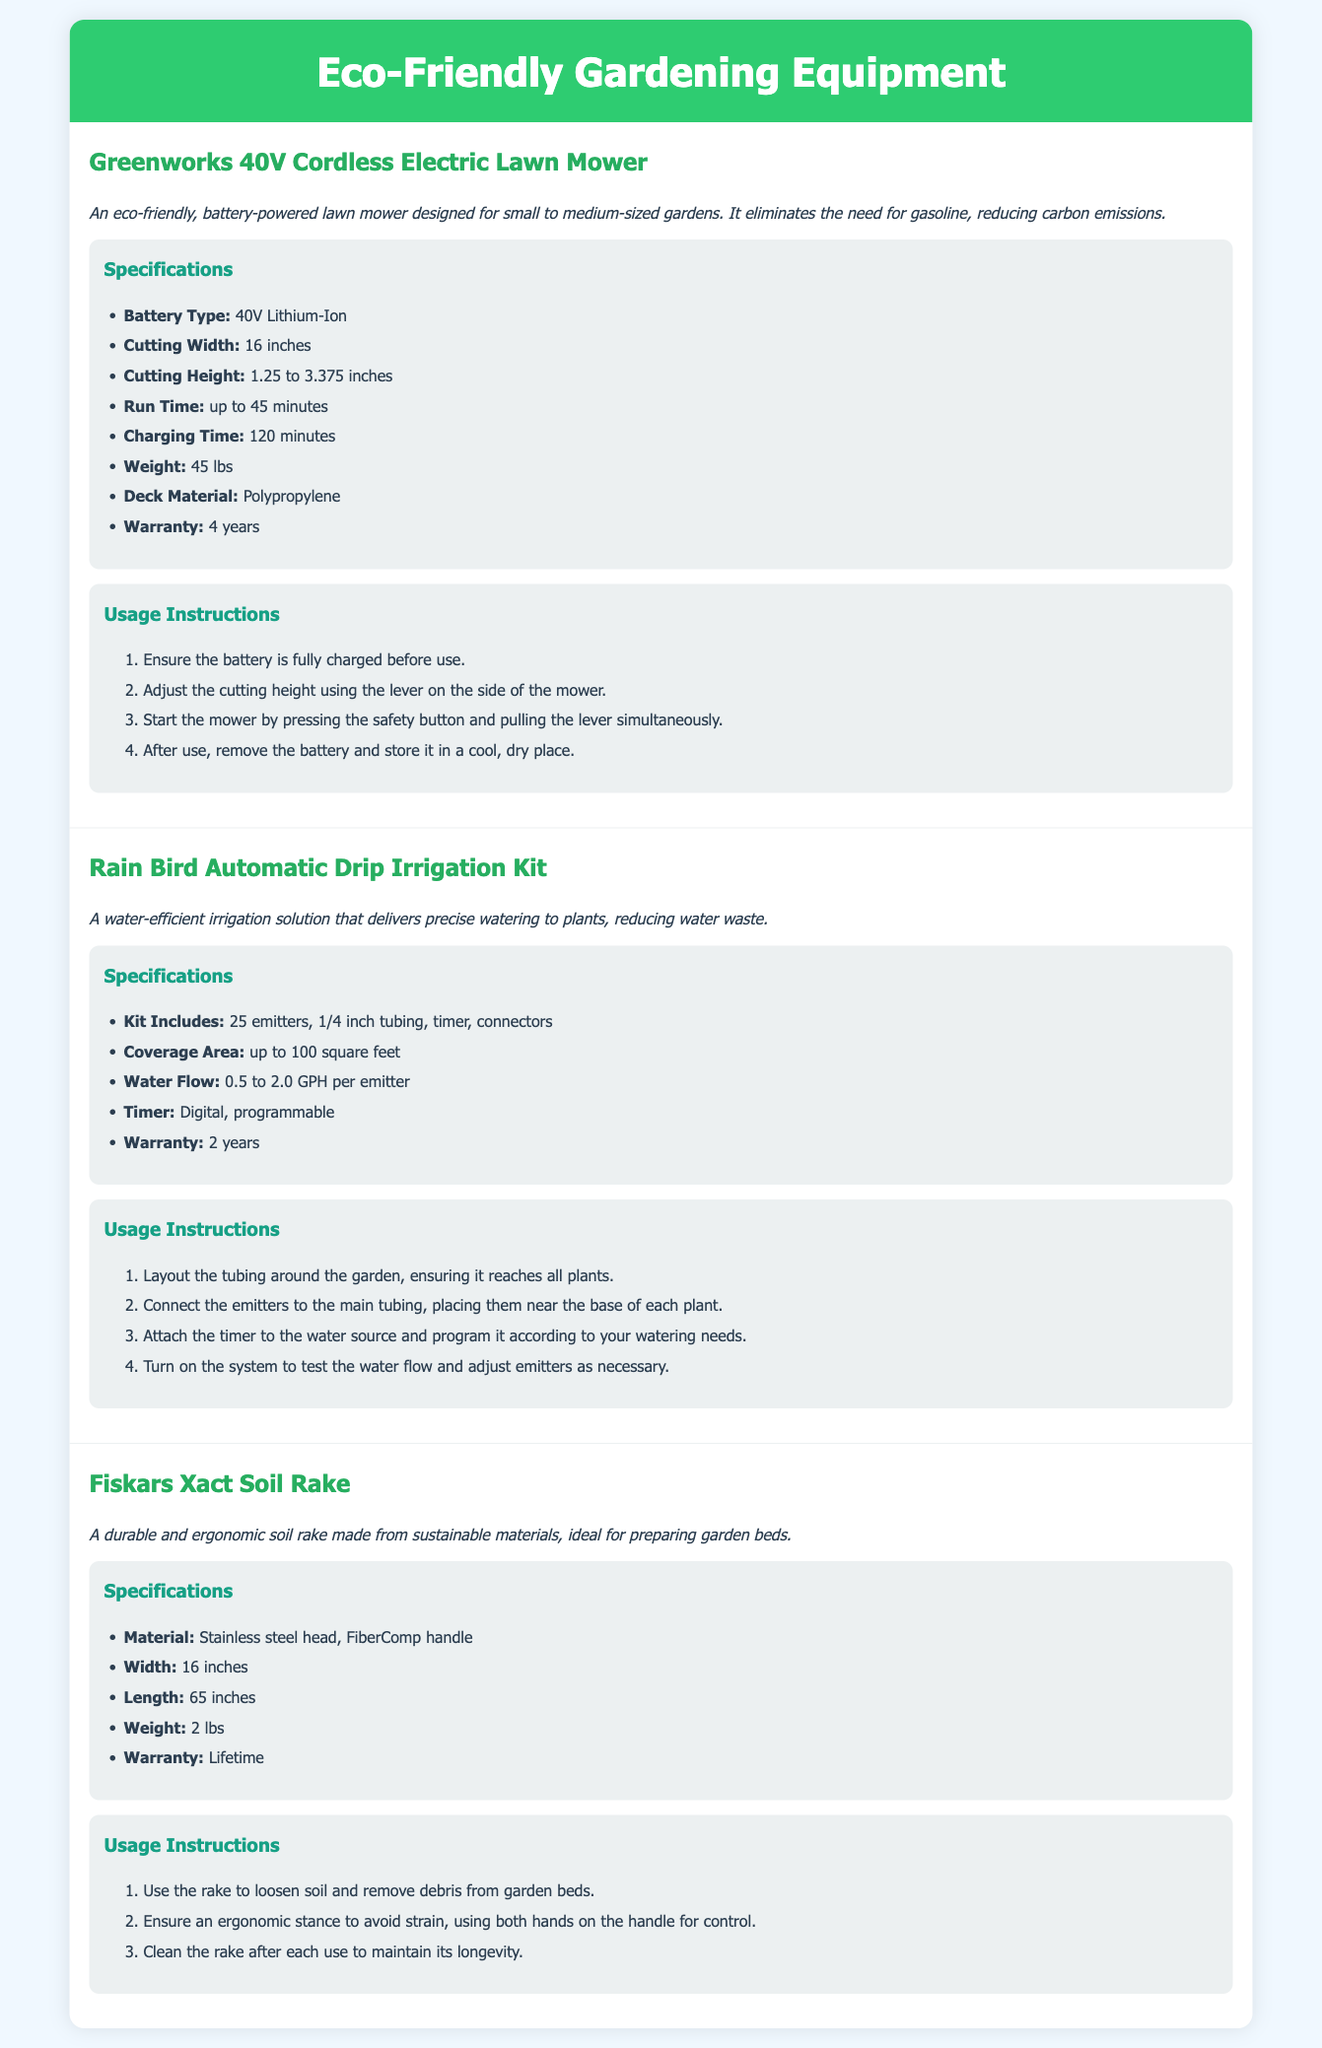what is the battery type of the Greenworks lawn mower? The battery type is specifically mentioned in the specifications of the Greenworks lawn mower.
Answer: 40V Lithium-Ion what is the cutting width of the Greenworks lawn mower? The cutting width is detailed among the specifications for the Greenworks lawn mower.
Answer: 16 inches how many emitters are included in the Rain Bird irrigation kit? The number of emitters is listed under the specifications of the Rain Bird irrigation kit.
Answer: 25 emitters what is the warranty period for the Fiskars soil rake? The warranty period is provided in the specifications section for the Fiskars soil rake.
Answer: Lifetime what is the run time for the Greenworks lawn mower? The run time is stated in the specifications section for the Greenworks lawn mower.
Answer: up to 45 minutes how does the Rain Bird irrigation kit reduce water waste? The Rain Bird irrigation kit offers a precise watering solution, which reduces overall water usage in gardening.
Answer: By delivering precise watering what is the optimal cutting height range for the Greenworks lawn mower? The optimal cutting height range is given in the specifications for the Greenworks lawn mower.
Answer: 1.25 to 3.375 inches what material is the handle of the Fiskars soil rake made from? The material of the handle is specified in the specs section of the Fiskars soil rake.
Answer: FiberComp what should be done after using the Greenworks lawn mower? The instructions section outlines the steps to follow after using the lawn mower.
Answer: Remove the battery and store it how long is the charging time for the Greenworks lawn mower? The charging time is mentioned in the specifications list for the Greenworks lawn mower.
Answer: 120 minutes 